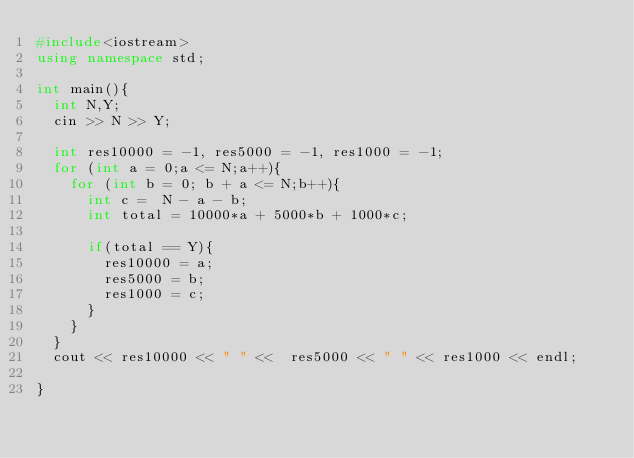<code> <loc_0><loc_0><loc_500><loc_500><_C++_>#include<iostream>
using namespace std;

int main(){
  int N,Y;
  cin >> N >> Y;
  
  int res10000 = -1, res5000 = -1, res1000 = -1;
  for (int a = 0;a <= N;a++){
    for (int b = 0; b + a <= N;b++){
      int c =  N - a - b;
      int total = 10000*a + 5000*b + 1000*c;
      
      if(total == Y){
        res10000 = a;
        res5000 = b;
        res1000 = c;
      }
    }
  }
  cout << res10000 << " " <<  res5000 << " " << res1000 << endl;
  
}
        
    </code> 